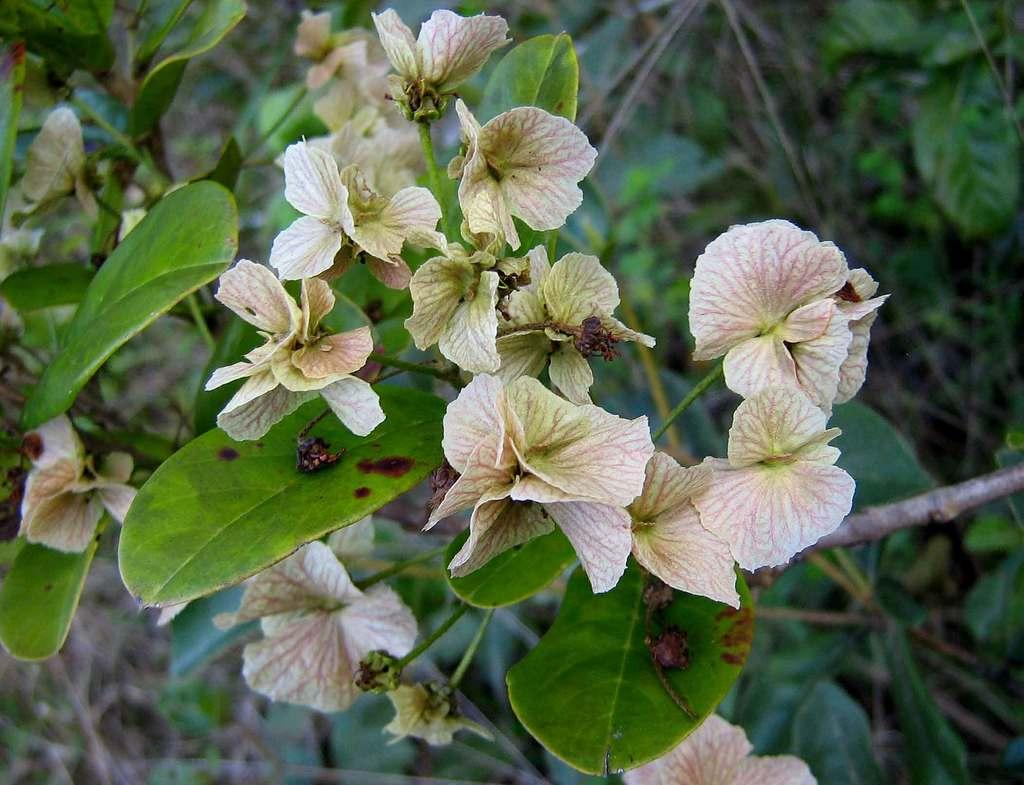What type of plant life can be seen in the image? There are flowers, leaves, and a stem visible in the image. What else can be seen in the background of the image? There are plants in the background of the image. What is the name of the person who created the flowers in the image? The image does not provide information about the person who created the flowers, as flowers are a natural occurrence and not created by a specific person. 